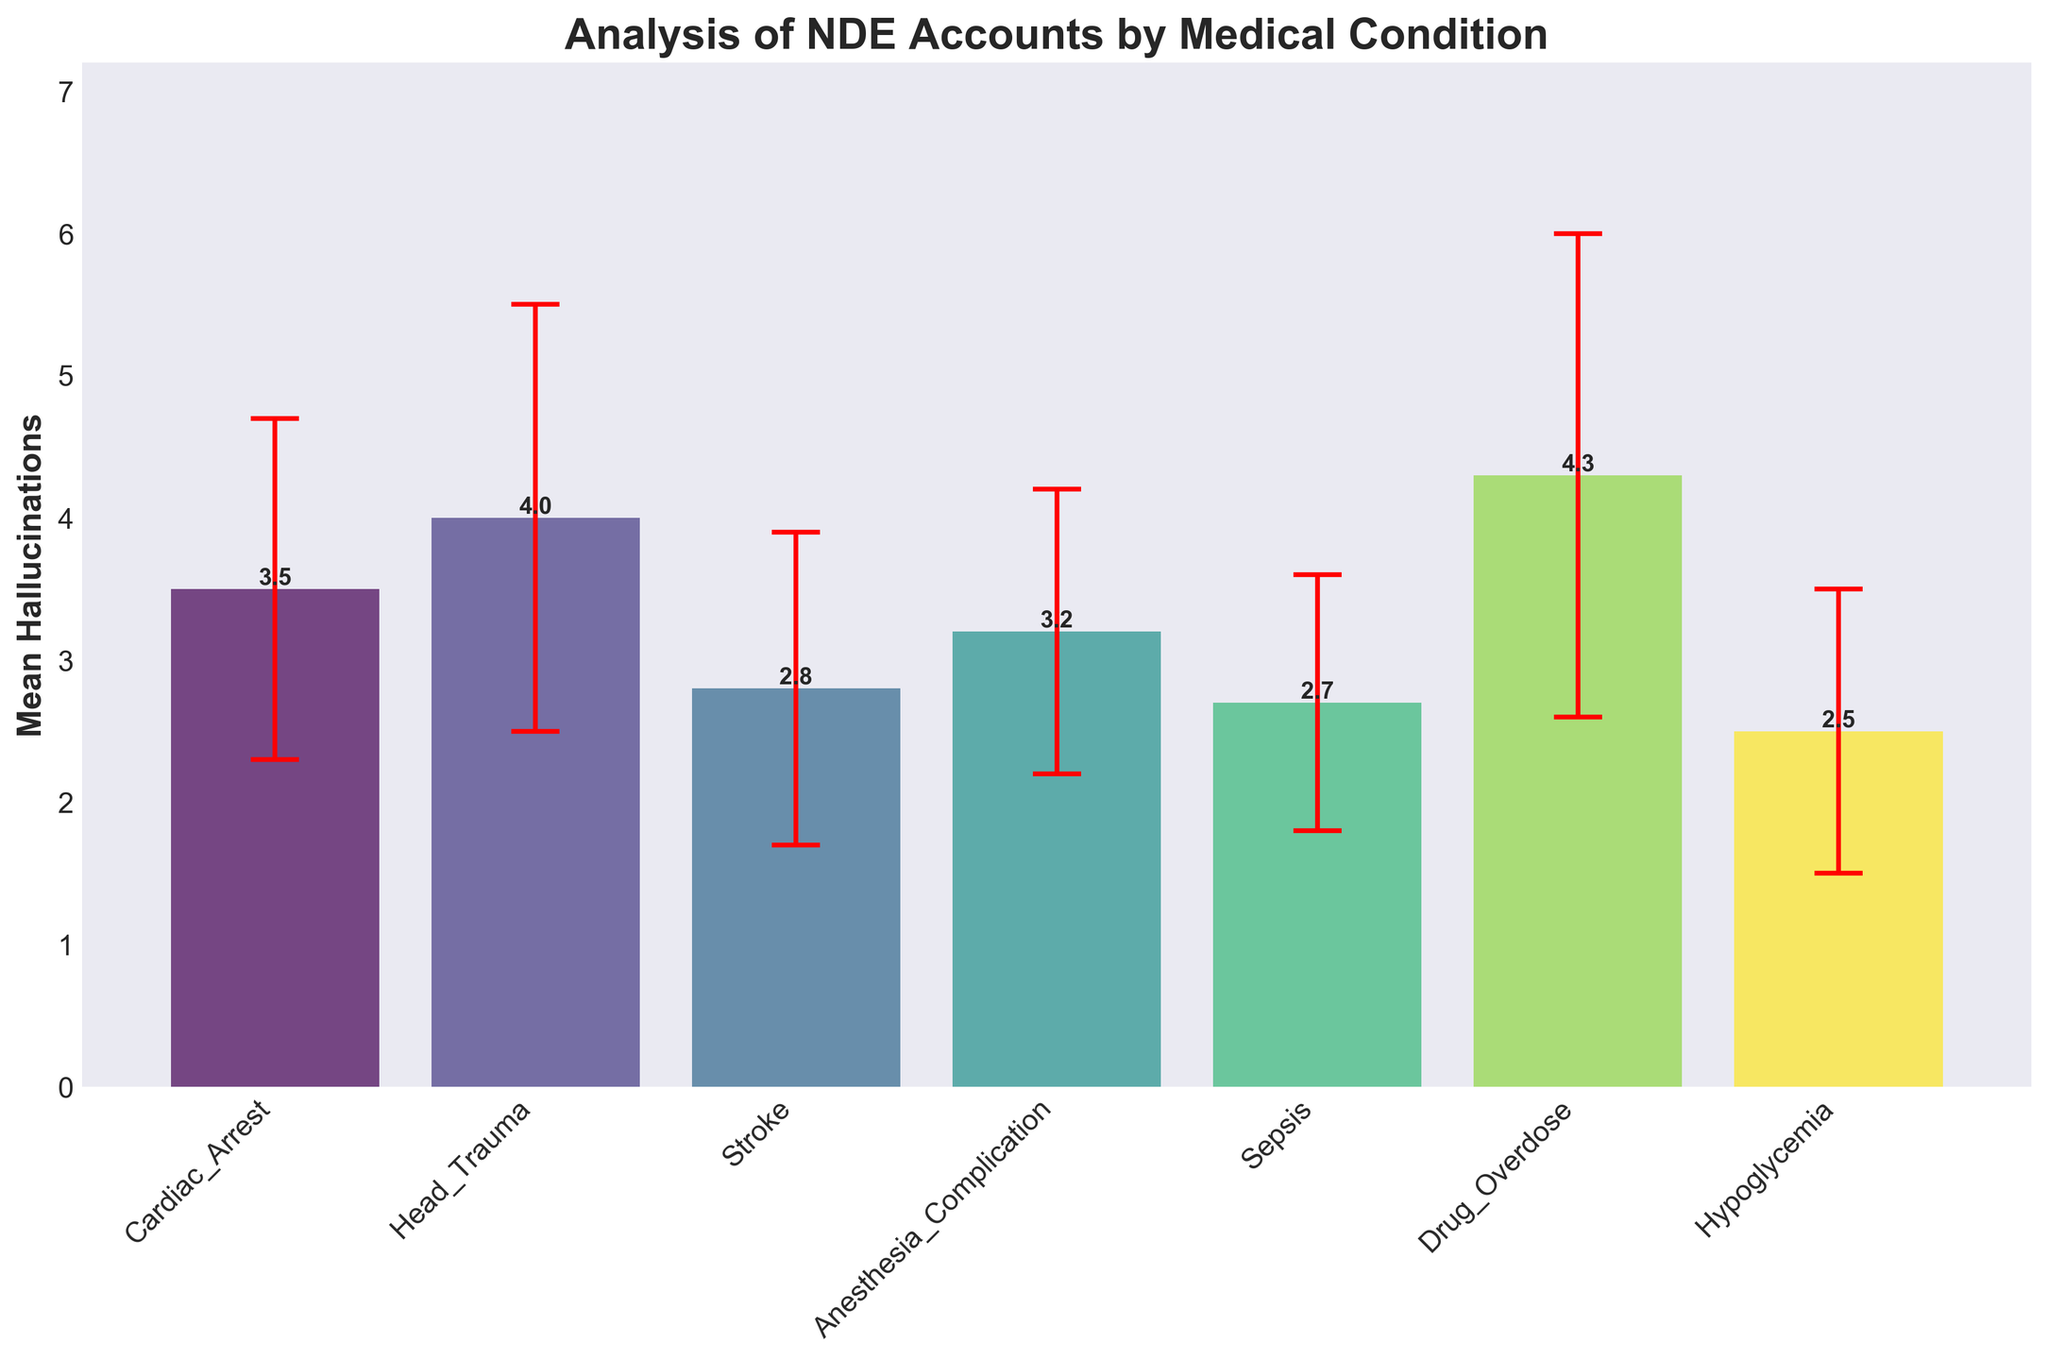Which medical condition shows the highest mean hallucinations? By observing the height of the bars representing mean hallucinations, the bar for Drug Overdose is the highest, indicating the highest mean hallucinations.
Answer: Drug Overdose What is the mean hallucinations value for Head Trauma? By looking at the bar labeled for Head Trauma, the number at the top of the bar indicates the mean hallucinations value.
Answer: 4.0 Which medical condition has the smallest variance in reported hallucinations? The variance is represented by the length of the error bars. The shortest error bar corresponds to Sepsis.
Answer: Sepsis How does the mean hallucinations for Cardiac Arrest compare to that for Stroke? Compare the height of the bars for Cardiac Arrest and Stroke. The Cardiac Arrest bar is higher than Stroke.
Answer: Cardiac Arrest is higher What is the combined mean hallucinations value for Anesthesia Complication and Hypoglycemia? Add the mean hallucinations for Anesthesia Complication (3.2) and Hypoglycemia (2.5).
Answer: 5.7 Which medical condition has the highest standard deviation in hallucinations? The standard deviation is indicated by the length of the error bars. The longest error bar corresponds to Drug Overdose.
Answer: Drug Overdose What's the difference in mean hallucinations between the condition with the highest mean and the condition with the lowest mean? Subtract the mean hallucinations of Hypoglycemia (2.5) from Drug Overdose (4.3).
Answer: 1.8 How many medical conditions have a mean hallucinations value above 3.0? By counting the bars whose height is above the 3.0 mark on the y-axis.
Answer: 4 What is the mean hallucinations value represented by the highest bar on the plot? The tallest bar represents Drug Overdose and the number at the top of the bar indicates the mean hallucinations value.
Answer: 4.3 